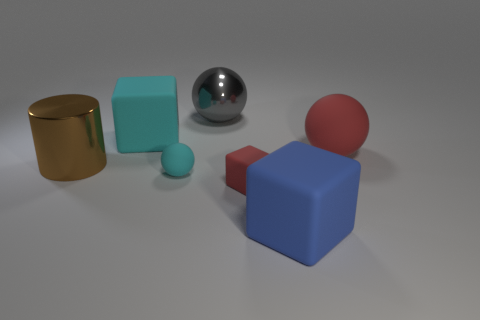What number of tiny things are either yellow metal cylinders or red matte cubes?
Keep it short and to the point. 1. Does the cyan sphere have the same size as the red rubber thing that is left of the blue object?
Make the answer very short. Yes. Is there any other thing that is the same shape as the brown metal object?
Provide a short and direct response. No. How many cyan cubes are there?
Provide a succinct answer. 1. What number of red things are either tiny matte blocks or rubber spheres?
Keep it short and to the point. 2. Do the red object to the right of the small red matte cube and the small red thing have the same material?
Your answer should be very brief. Yes. How many other things are made of the same material as the large blue block?
Your response must be concise. 4. What is the material of the big gray ball?
Provide a short and direct response. Metal. How big is the rubber ball that is to the left of the tiny red thing?
Ensure brevity in your answer.  Small. There is a big rubber object that is in front of the brown thing; what number of matte cubes are in front of it?
Your response must be concise. 0. 